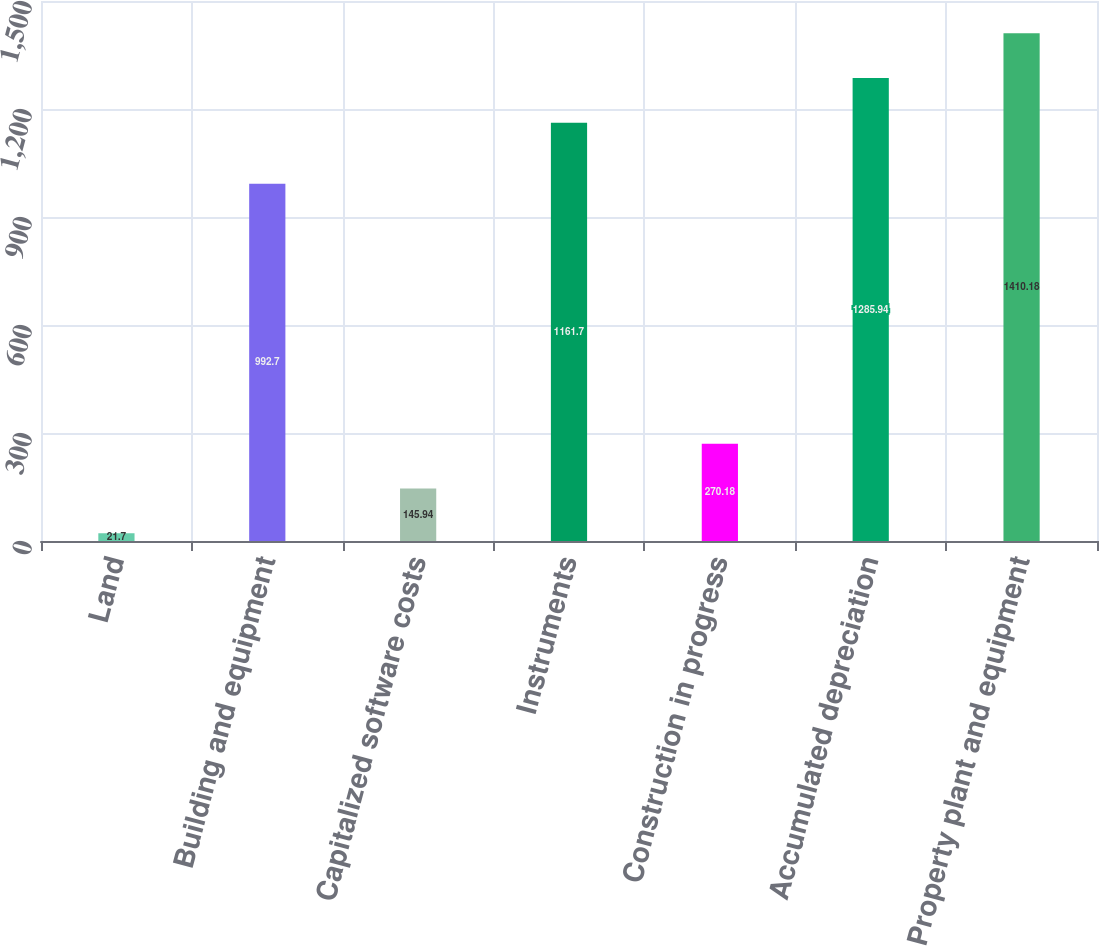Convert chart to OTSL. <chart><loc_0><loc_0><loc_500><loc_500><bar_chart><fcel>Land<fcel>Building and equipment<fcel>Capitalized software costs<fcel>Instruments<fcel>Construction in progress<fcel>Accumulated depreciation<fcel>Property plant and equipment<nl><fcel>21.7<fcel>992.7<fcel>145.94<fcel>1161.7<fcel>270.18<fcel>1285.94<fcel>1410.18<nl></chart> 